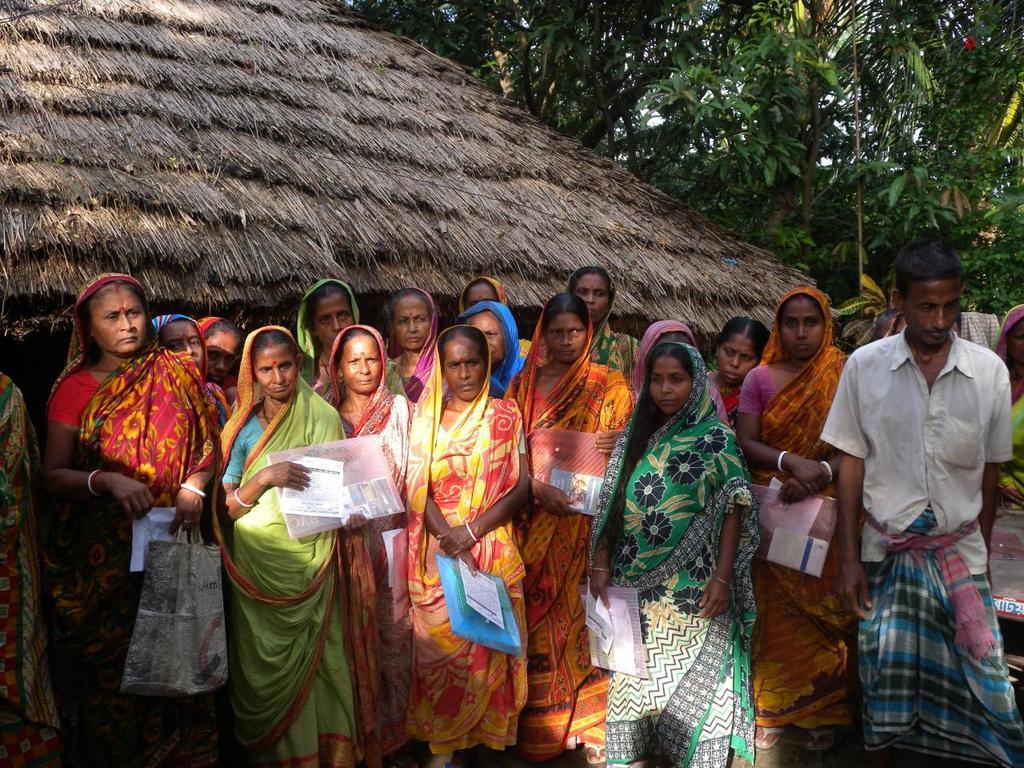Please provide a concise description of this image. In this image I can see number of persons are standing on the ground and holding few covers in their hands. In the background I can see the roof of the building and few trees which are green in color. 